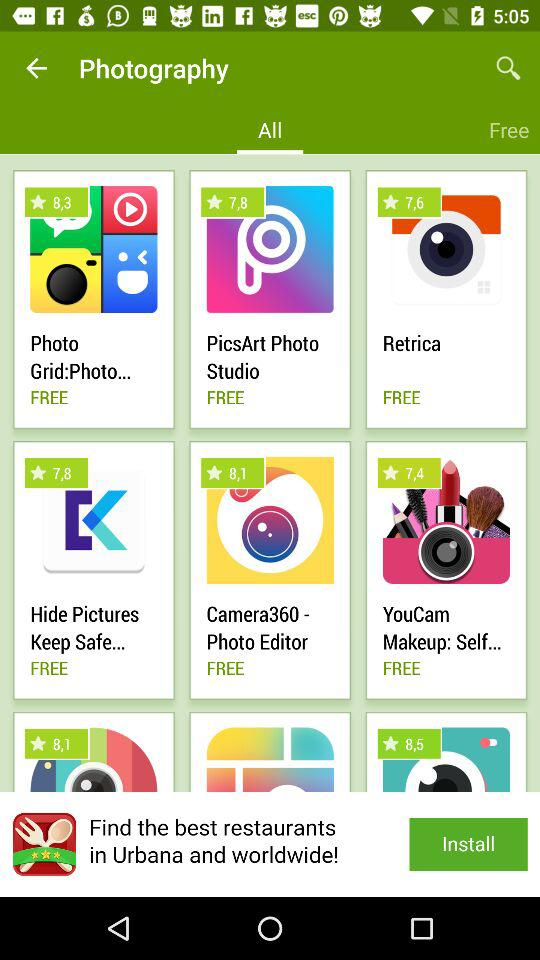Which tab is currently selected? The currently selected tab is "All". 